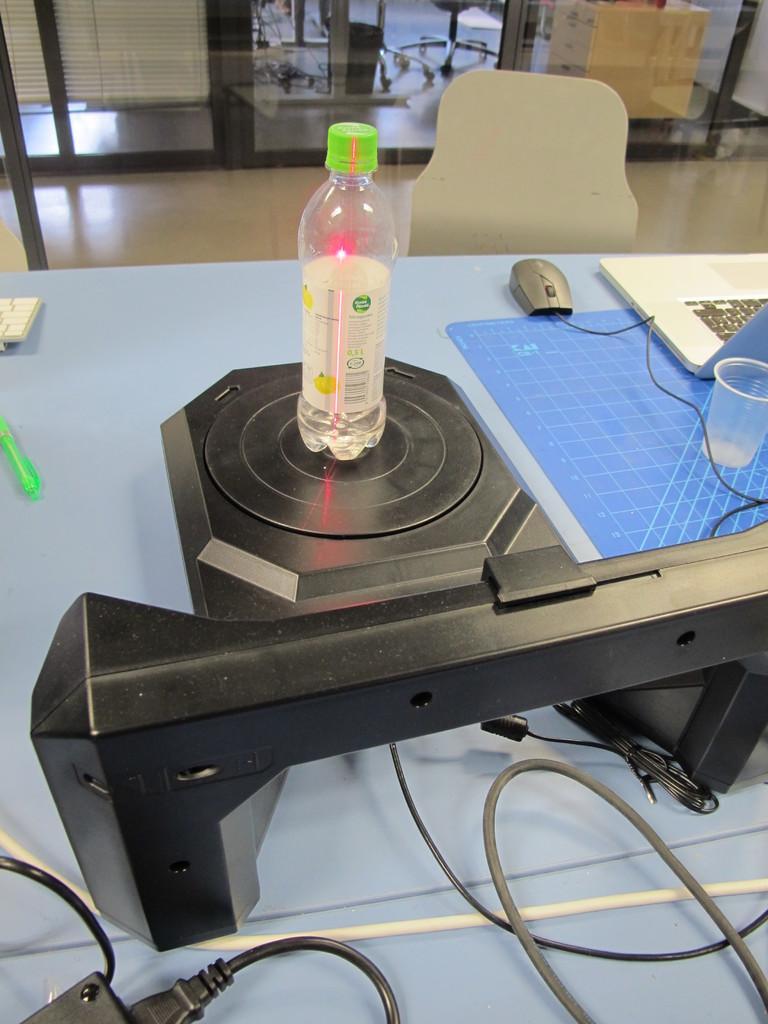In one or two sentences, can you explain what this image depicts? This is an inside view. On the bottom of the image there is a table. On the table I can see few material, one bottle, one glass, laptop and a mouse. Just beside the table there is a chair. In the background I can see a box and glass. 